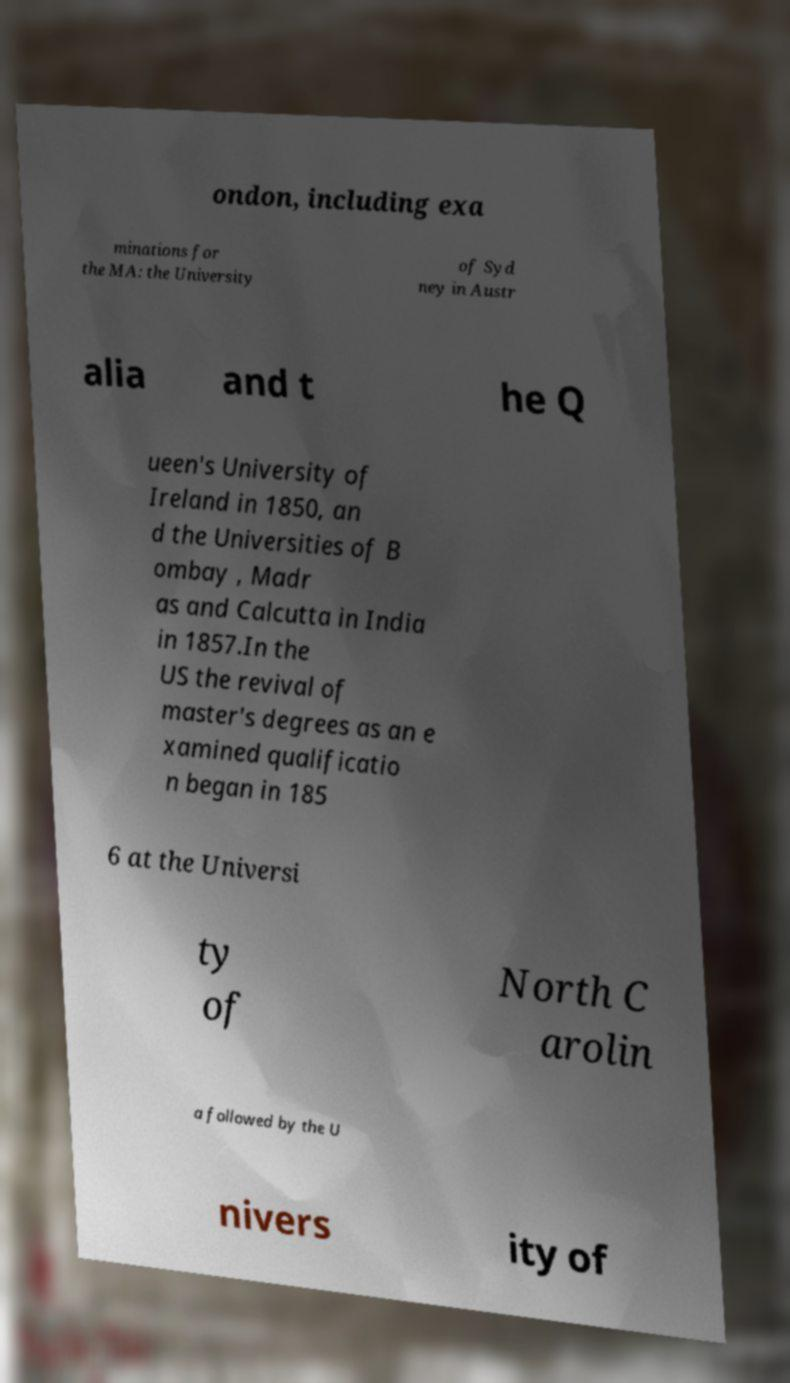Could you extract and type out the text from this image? ondon, including exa minations for the MA: the University of Syd ney in Austr alia and t he Q ueen's University of Ireland in 1850, an d the Universities of B ombay , Madr as and Calcutta in India in 1857.In the US the revival of master's degrees as an e xamined qualificatio n began in 185 6 at the Universi ty of North C arolin a followed by the U nivers ity of 